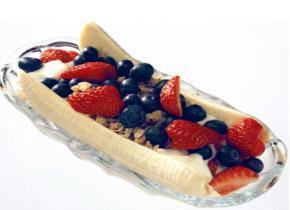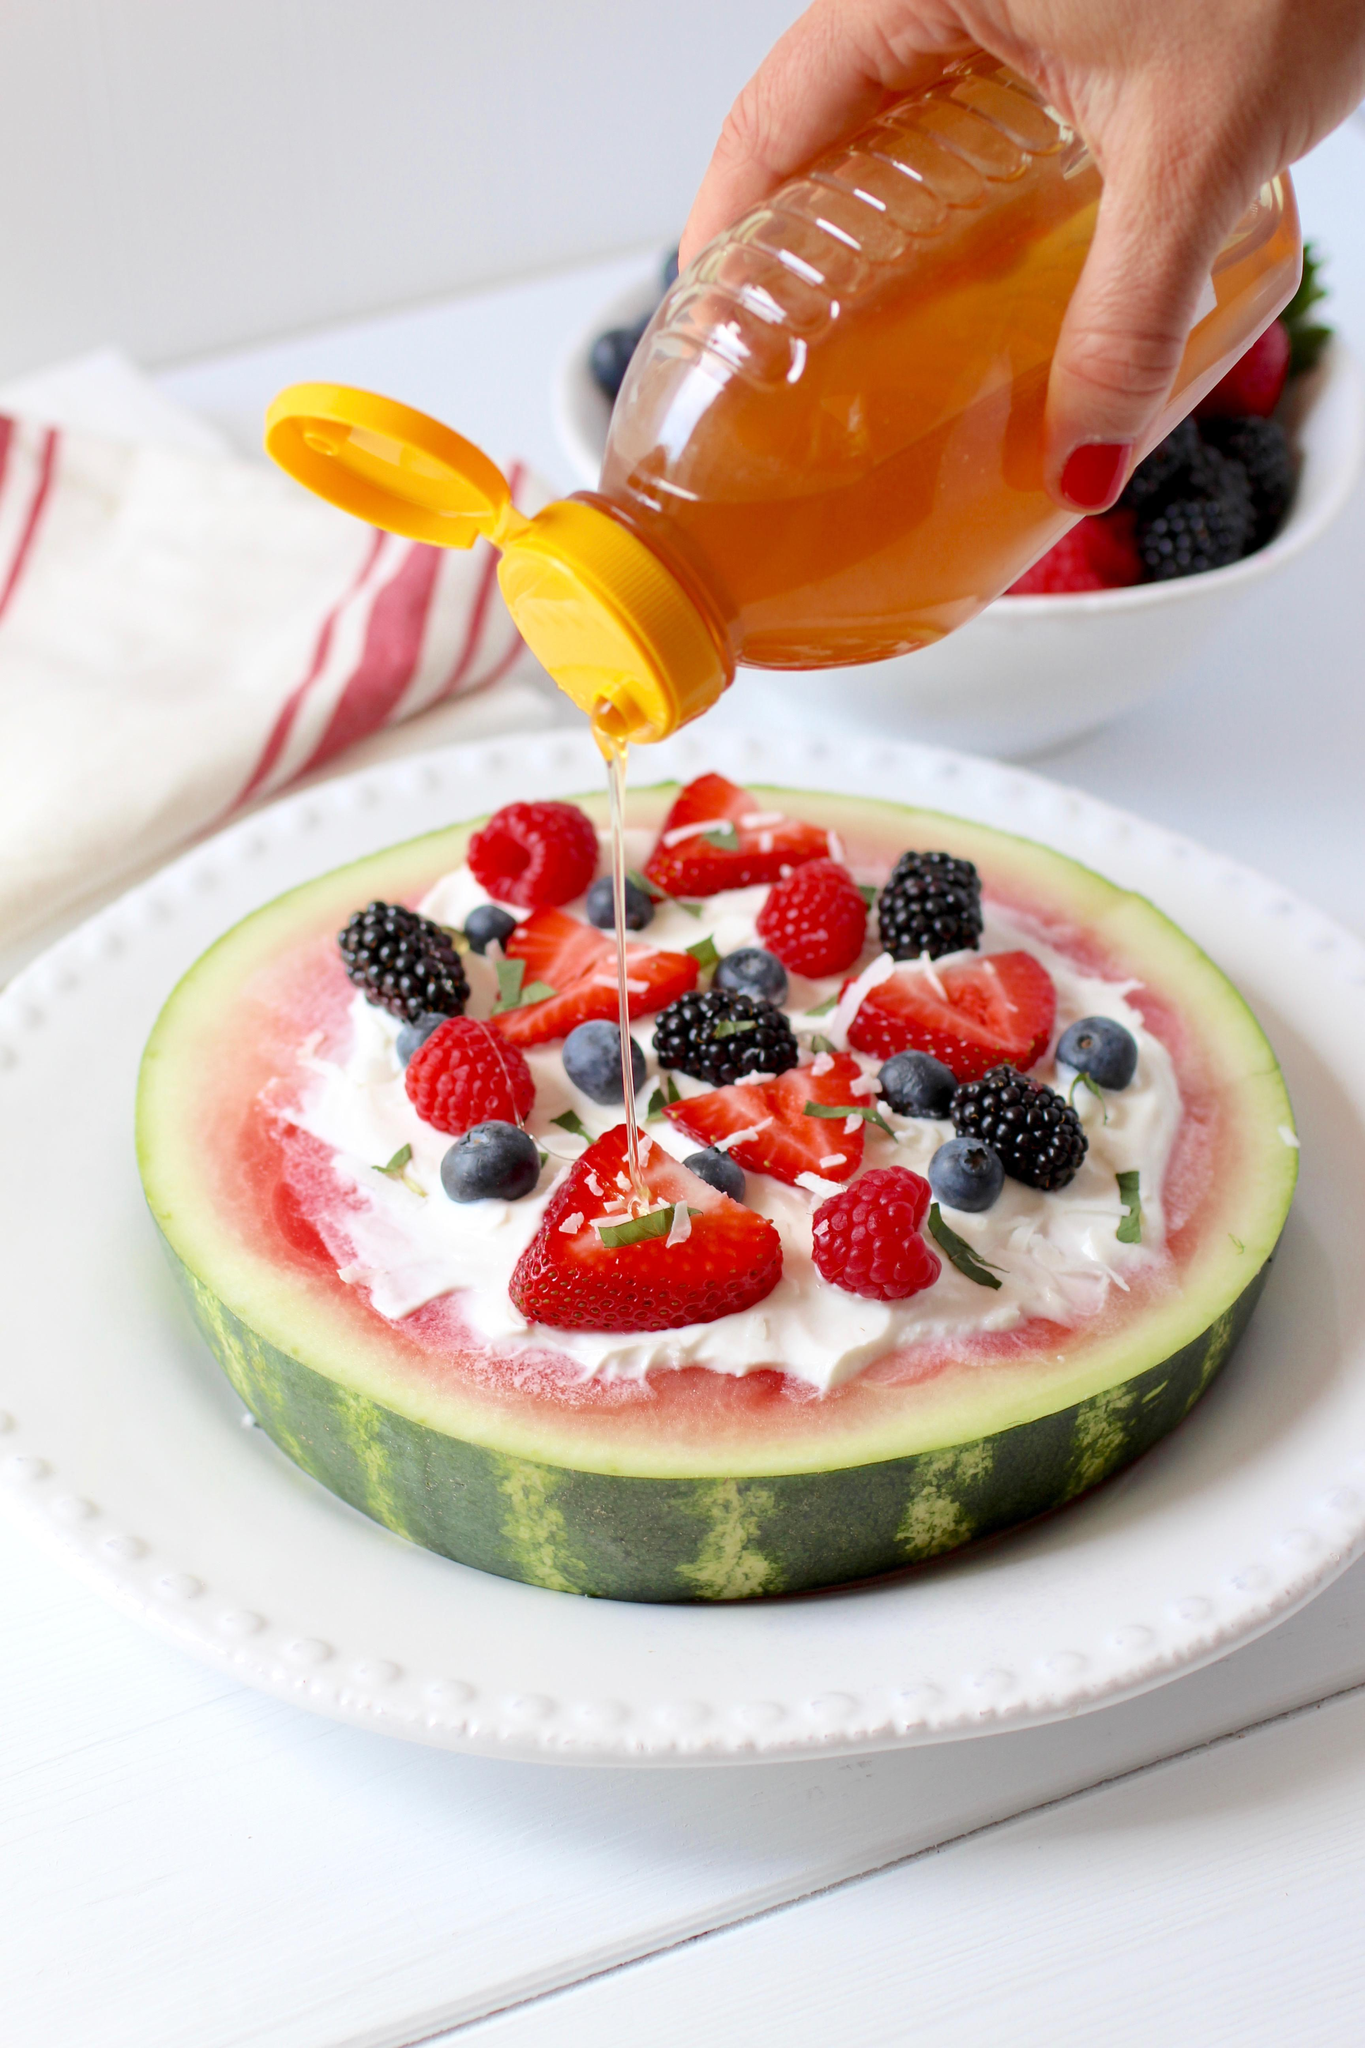The first image is the image on the left, the second image is the image on the right. For the images displayed, is the sentence "The left image includes an oblong clear glass bowl containing a split banana with blueberries and other toppings on it." factually correct? Answer yes or no. Yes. The first image is the image on the left, the second image is the image on the right. For the images displayed, is the sentence "There are round banana slices." factually correct? Answer yes or no. No. 